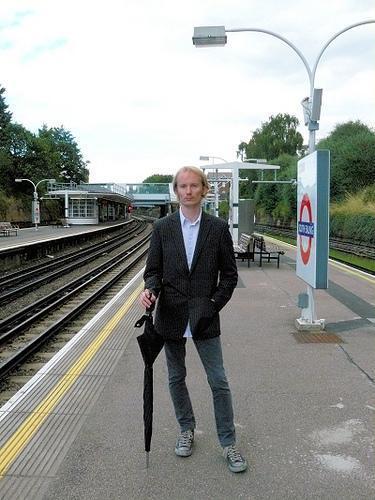How many dinosaurs are in the picture?
Give a very brief answer. 0. How many cars are there?
Give a very brief answer. 0. 